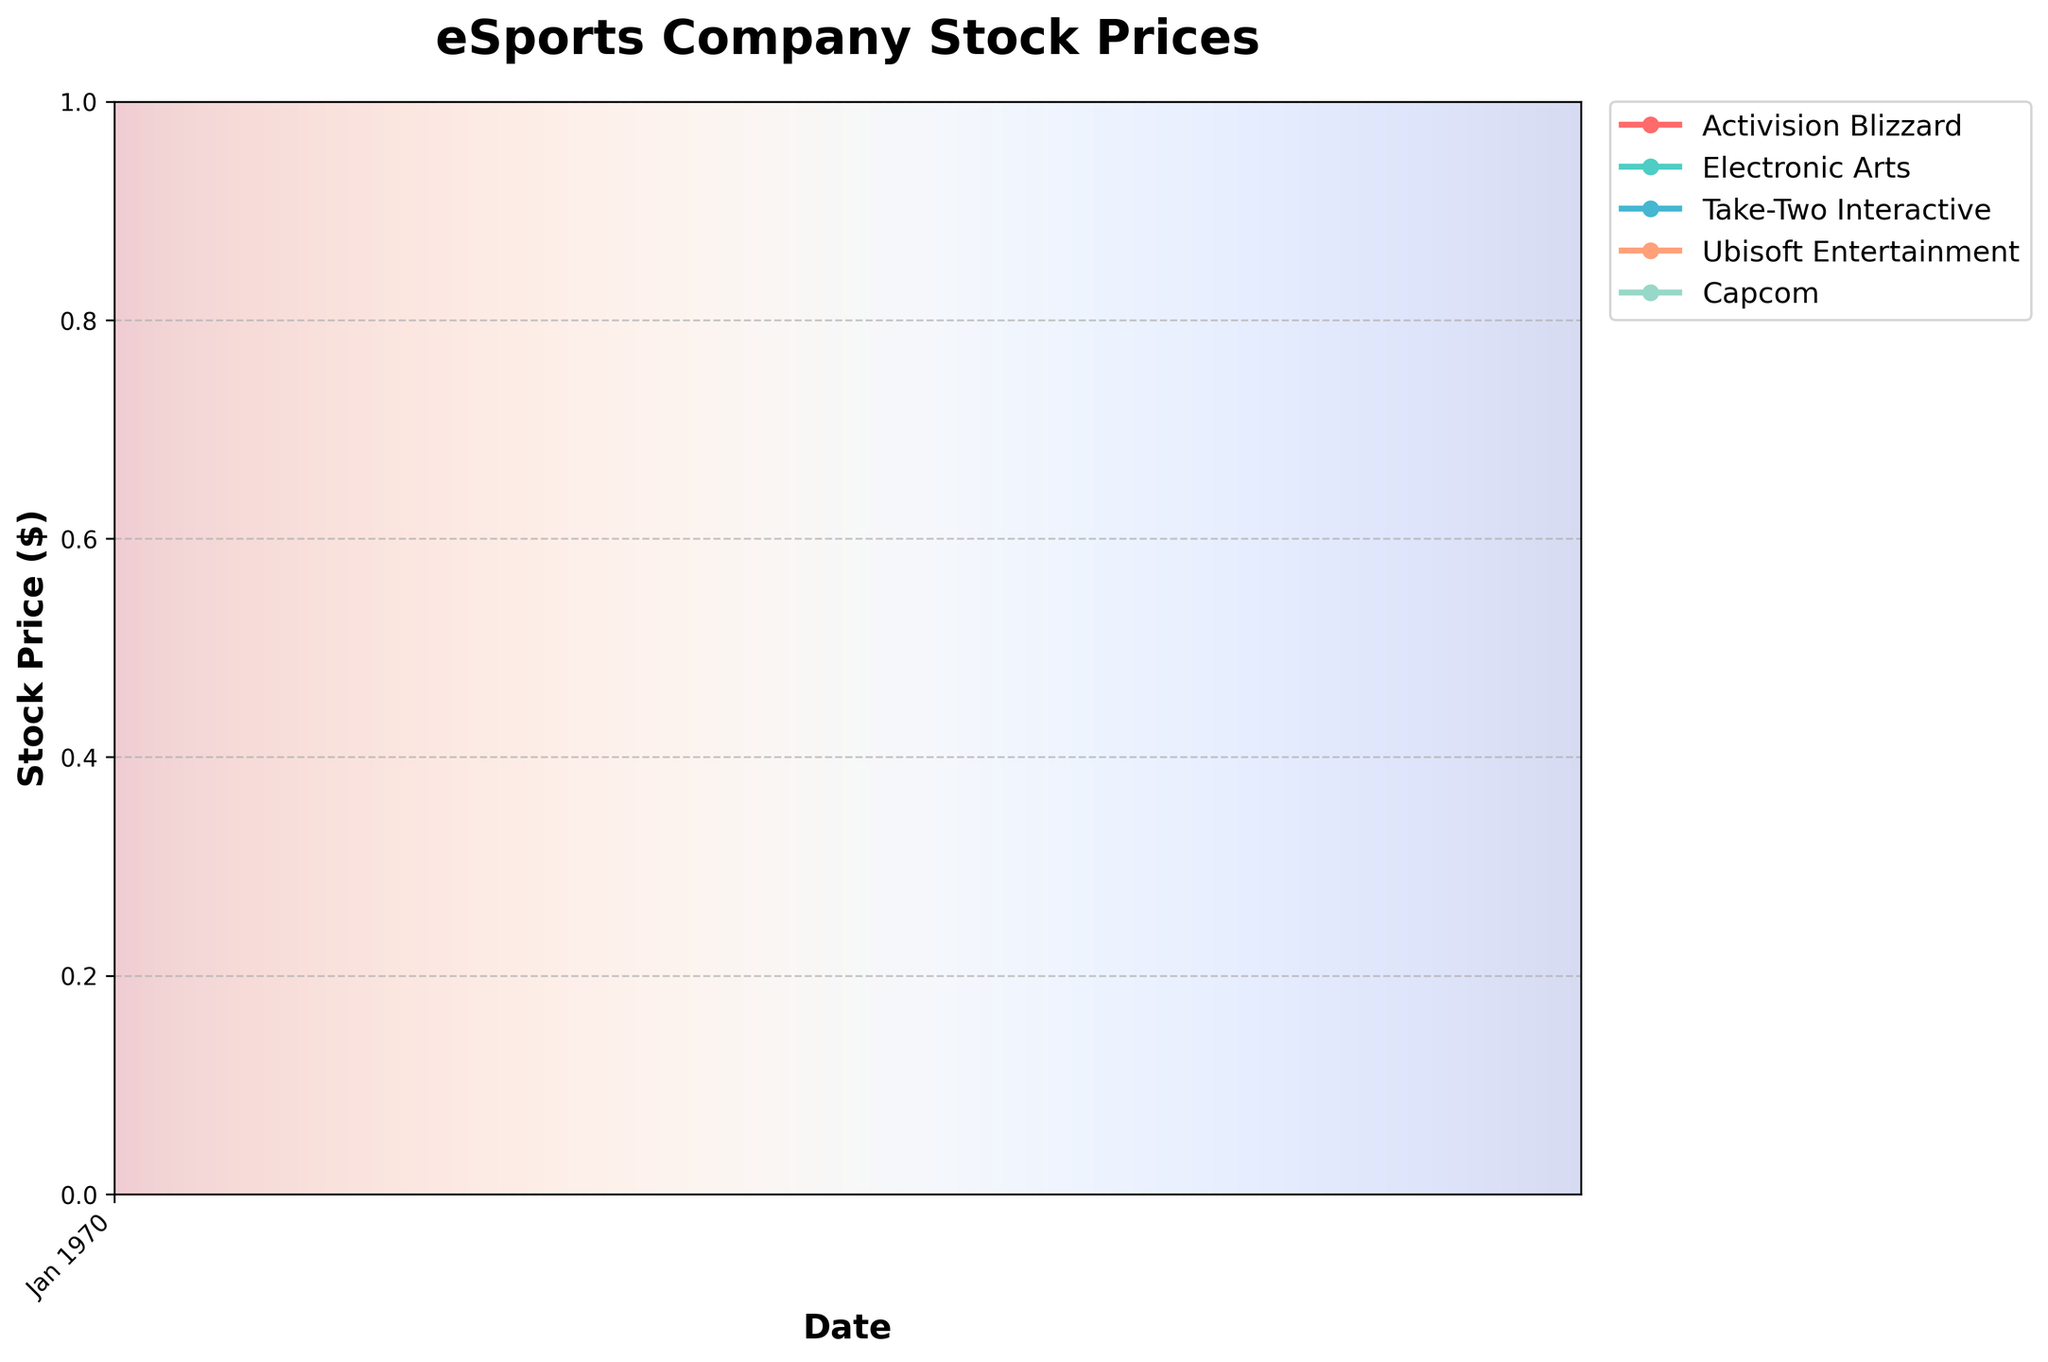What's the title of the figure? The title is typically found at the top center of the plot and often in a larger font size. It provides an overview of what the data represents.
Answer: eSports Company Stock Prices What is the stock price of Activision Blizzard on October 1st, 2023? Locate the line for Activision Blizzard, represented by one of the colored lines, and find the point corresponding to October 1st, 2023 on the x-axis. Then, read the y-axis value at this point.
Answer: $122.50 Which company had the highest stock price on December 15th, 2023? Look at the stock prices for all companies on December 15th, 2023. Compare these values to determine which is the highest.
Answer: Take-Two Interactive By how much did Ubisoft Entertainment's stock price increase from January 1st to December 15th, 2023? Find Ubisoft Entertainment's stock price on January 1st, 2023 and its price on December 15th, 2023. Subtract the January price from the December price.
Answer: $60.00 Which company showed the most consistent upward trend throughout the year? Look at the slope of each company's line from January to December. A consistent upward trend will have a relatively uniform slope with no significant dips.
Answer: Activision Blizzard How many major data points (stock prices) are plotted for each company? Count the number of points marked on the plot for any single company, as each company should have the same number of points.
Answer: 24 Compare the stock price trends of Electronic Arts and Capcom from July 1st, 2023 to September 1st, 2023. Examine the segments of both companies' lines between July 1st and September 1st, noting any increases or decreases and the steepness of these slopes.
Answer: Both companies showed an upward trend, but Electronic Arts had a steeper increase What's the percentage increase in the stock price of Activision Blizzard from January 1st to July 1st, 2023? Calculate the initial and final stock prices for Activision Blizzard, then use the formula: \(\frac{\text{Final Price} - \text{Initial Price}}{\text{Initial Price}} \times 100\) to find the percentage increase.
Answer: 42.18% Which company had the highest stock price on March 1st, 2023? Check the stock prices for all companies on March 1st, 2023, and identify the highest value among them.
Answer: Take-Two Interactive On which date did Capcom's stock price first reach or exceed $35? Follow Capcom's stock price progression over time and note the earliest date it reached or surpassed $35.
Answer: June 15, 2023 